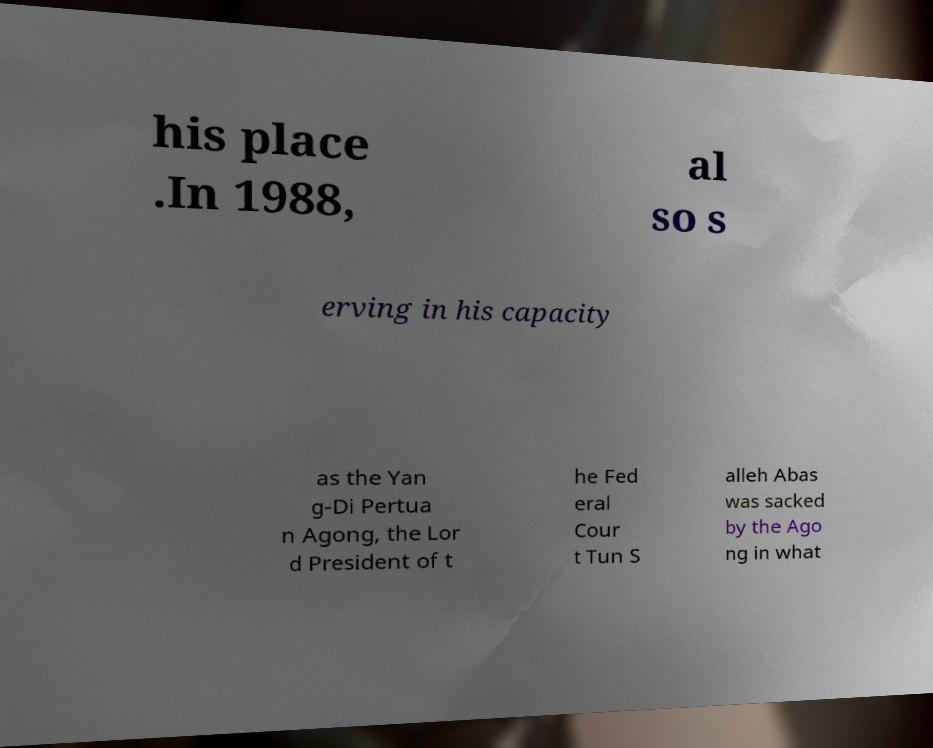For documentation purposes, I need the text within this image transcribed. Could you provide that? his place .In 1988, al so s erving in his capacity as the Yan g-Di Pertua n Agong, the Lor d President of t he Fed eral Cour t Tun S alleh Abas was sacked by the Ago ng in what 